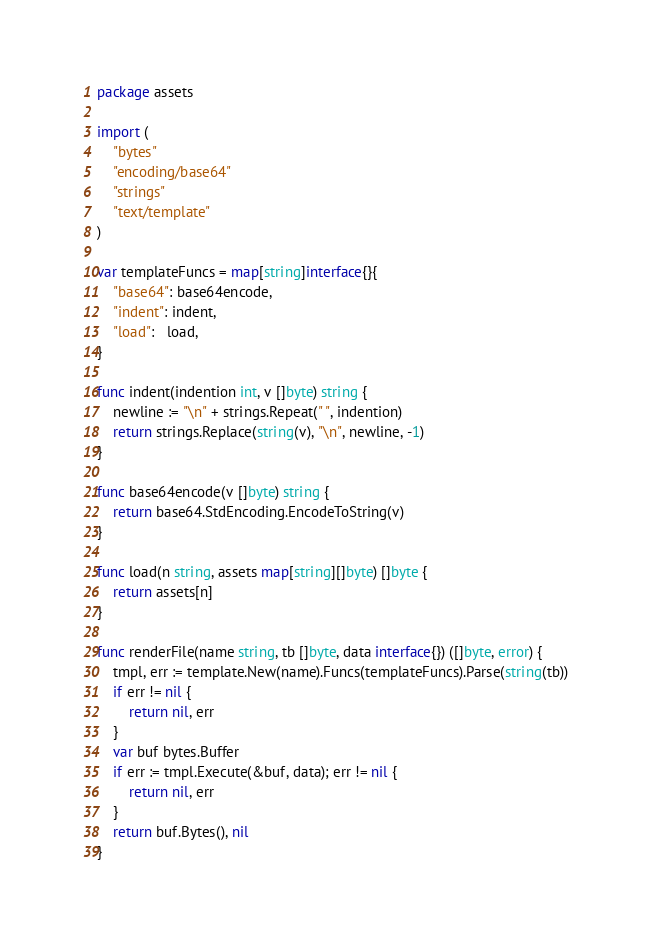<code> <loc_0><loc_0><loc_500><loc_500><_Go_>package assets

import (
	"bytes"
	"encoding/base64"
	"strings"
	"text/template"
)

var templateFuncs = map[string]interface{}{
	"base64": base64encode,
	"indent": indent,
	"load":   load,
}

func indent(indention int, v []byte) string {
	newline := "\n" + strings.Repeat(" ", indention)
	return strings.Replace(string(v), "\n", newline, -1)
}

func base64encode(v []byte) string {
	return base64.StdEncoding.EncodeToString(v)
}

func load(n string, assets map[string][]byte) []byte {
	return assets[n]
}

func renderFile(name string, tb []byte, data interface{}) ([]byte, error) {
	tmpl, err := template.New(name).Funcs(templateFuncs).Parse(string(tb))
	if err != nil {
		return nil, err
	}
	var buf bytes.Buffer
	if err := tmpl.Execute(&buf, data); err != nil {
		return nil, err
	}
	return buf.Bytes(), nil
}
</code> 